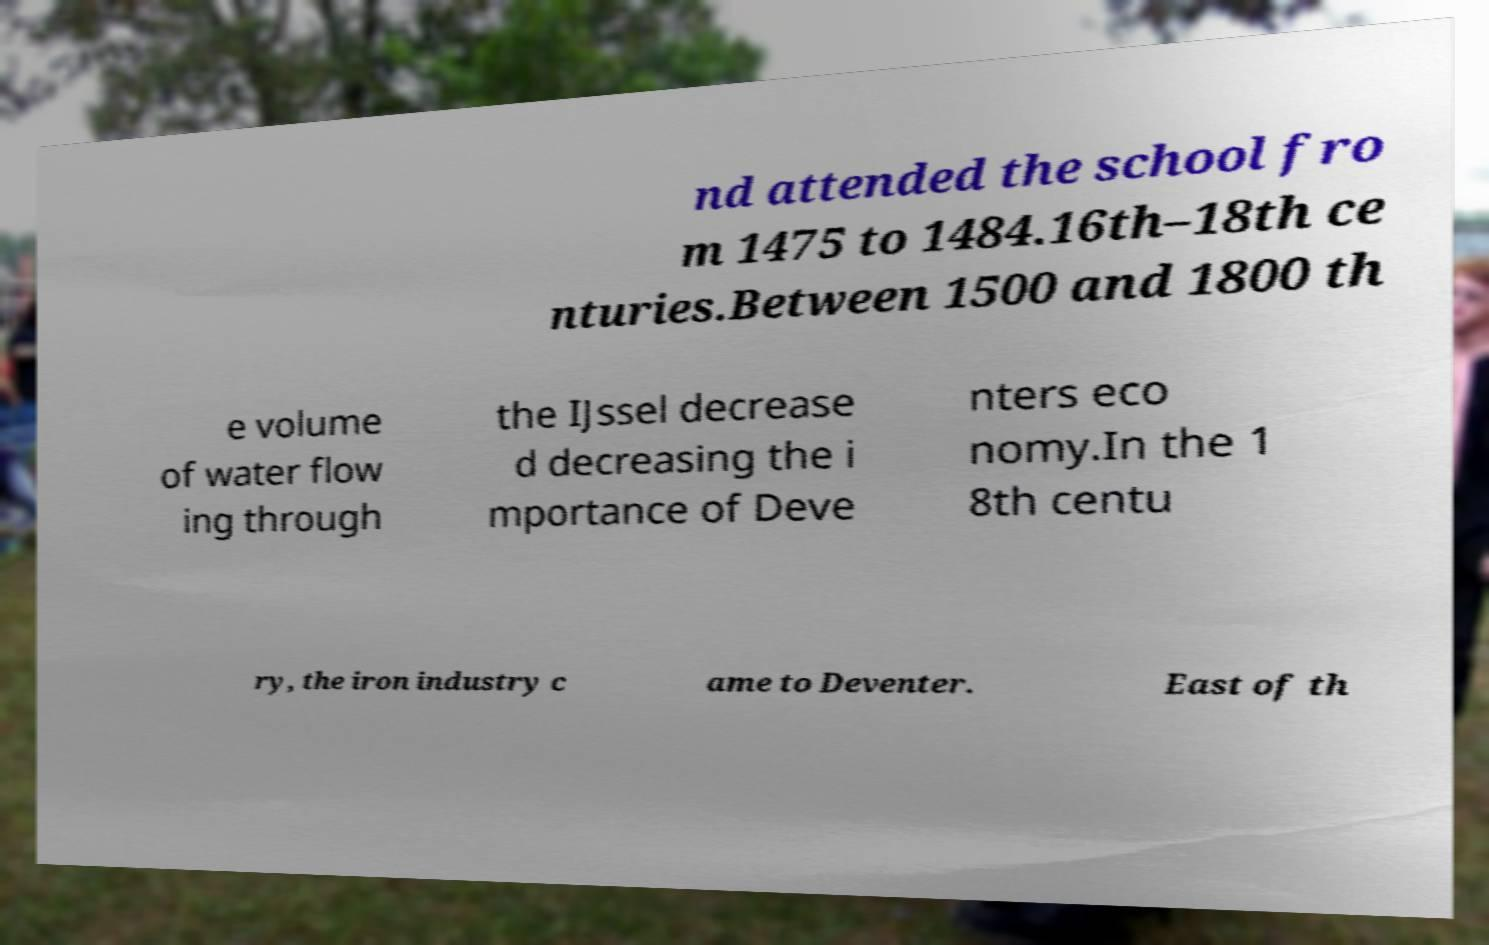What messages or text are displayed in this image? I need them in a readable, typed format. nd attended the school fro m 1475 to 1484.16th–18th ce nturies.Between 1500 and 1800 th e volume of water flow ing through the IJssel decrease d decreasing the i mportance of Deve nters eco nomy.In the 1 8th centu ry, the iron industry c ame to Deventer. East of th 